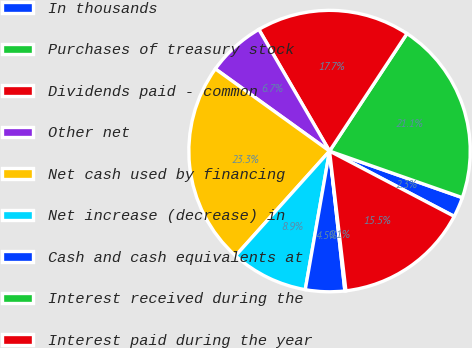Convert chart. <chart><loc_0><loc_0><loc_500><loc_500><pie_chart><fcel>In thousands<fcel>Purchases of treasury stock<fcel>Dividends paid - common<fcel>Other net<fcel>Net cash used by financing<fcel>Net increase (decrease) in<fcel>Cash and cash equivalents at<fcel>Interest received during the<fcel>Interest paid during the year<nl><fcel>2.31%<fcel>21.09%<fcel>17.65%<fcel>6.69%<fcel>23.28%<fcel>8.88%<fcel>4.5%<fcel>0.12%<fcel>15.46%<nl></chart> 